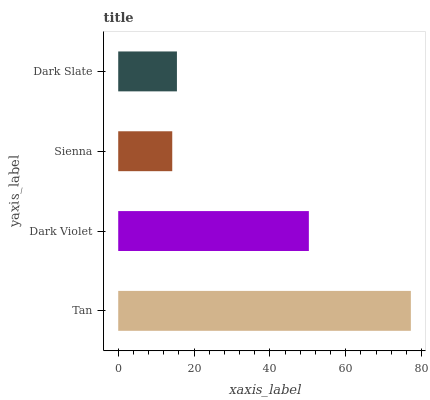Is Sienna the minimum?
Answer yes or no. Yes. Is Tan the maximum?
Answer yes or no. Yes. Is Dark Violet the minimum?
Answer yes or no. No. Is Dark Violet the maximum?
Answer yes or no. No. Is Tan greater than Dark Violet?
Answer yes or no. Yes. Is Dark Violet less than Tan?
Answer yes or no. Yes. Is Dark Violet greater than Tan?
Answer yes or no. No. Is Tan less than Dark Violet?
Answer yes or no. No. Is Dark Violet the high median?
Answer yes or no. Yes. Is Dark Slate the low median?
Answer yes or no. Yes. Is Tan the high median?
Answer yes or no. No. Is Dark Violet the low median?
Answer yes or no. No. 